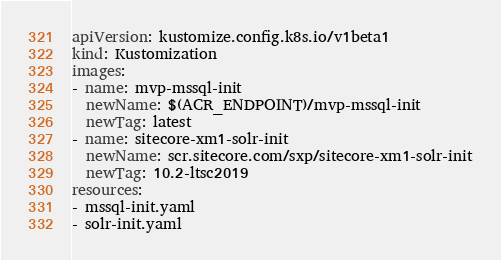Convert code to text. <code><loc_0><loc_0><loc_500><loc_500><_YAML_>apiVersion: kustomize.config.k8s.io/v1beta1
kind: Kustomization
images:
- name: mvp-mssql-init
  newName: $(ACR_ENDPOINT)/mvp-mssql-init
  newTag: latest
- name: sitecore-xm1-solr-init
  newName: scr.sitecore.com/sxp/sitecore-xm1-solr-init
  newTag: 10.2-ltsc2019
resources:
- mssql-init.yaml
- solr-init.yaml</code> 